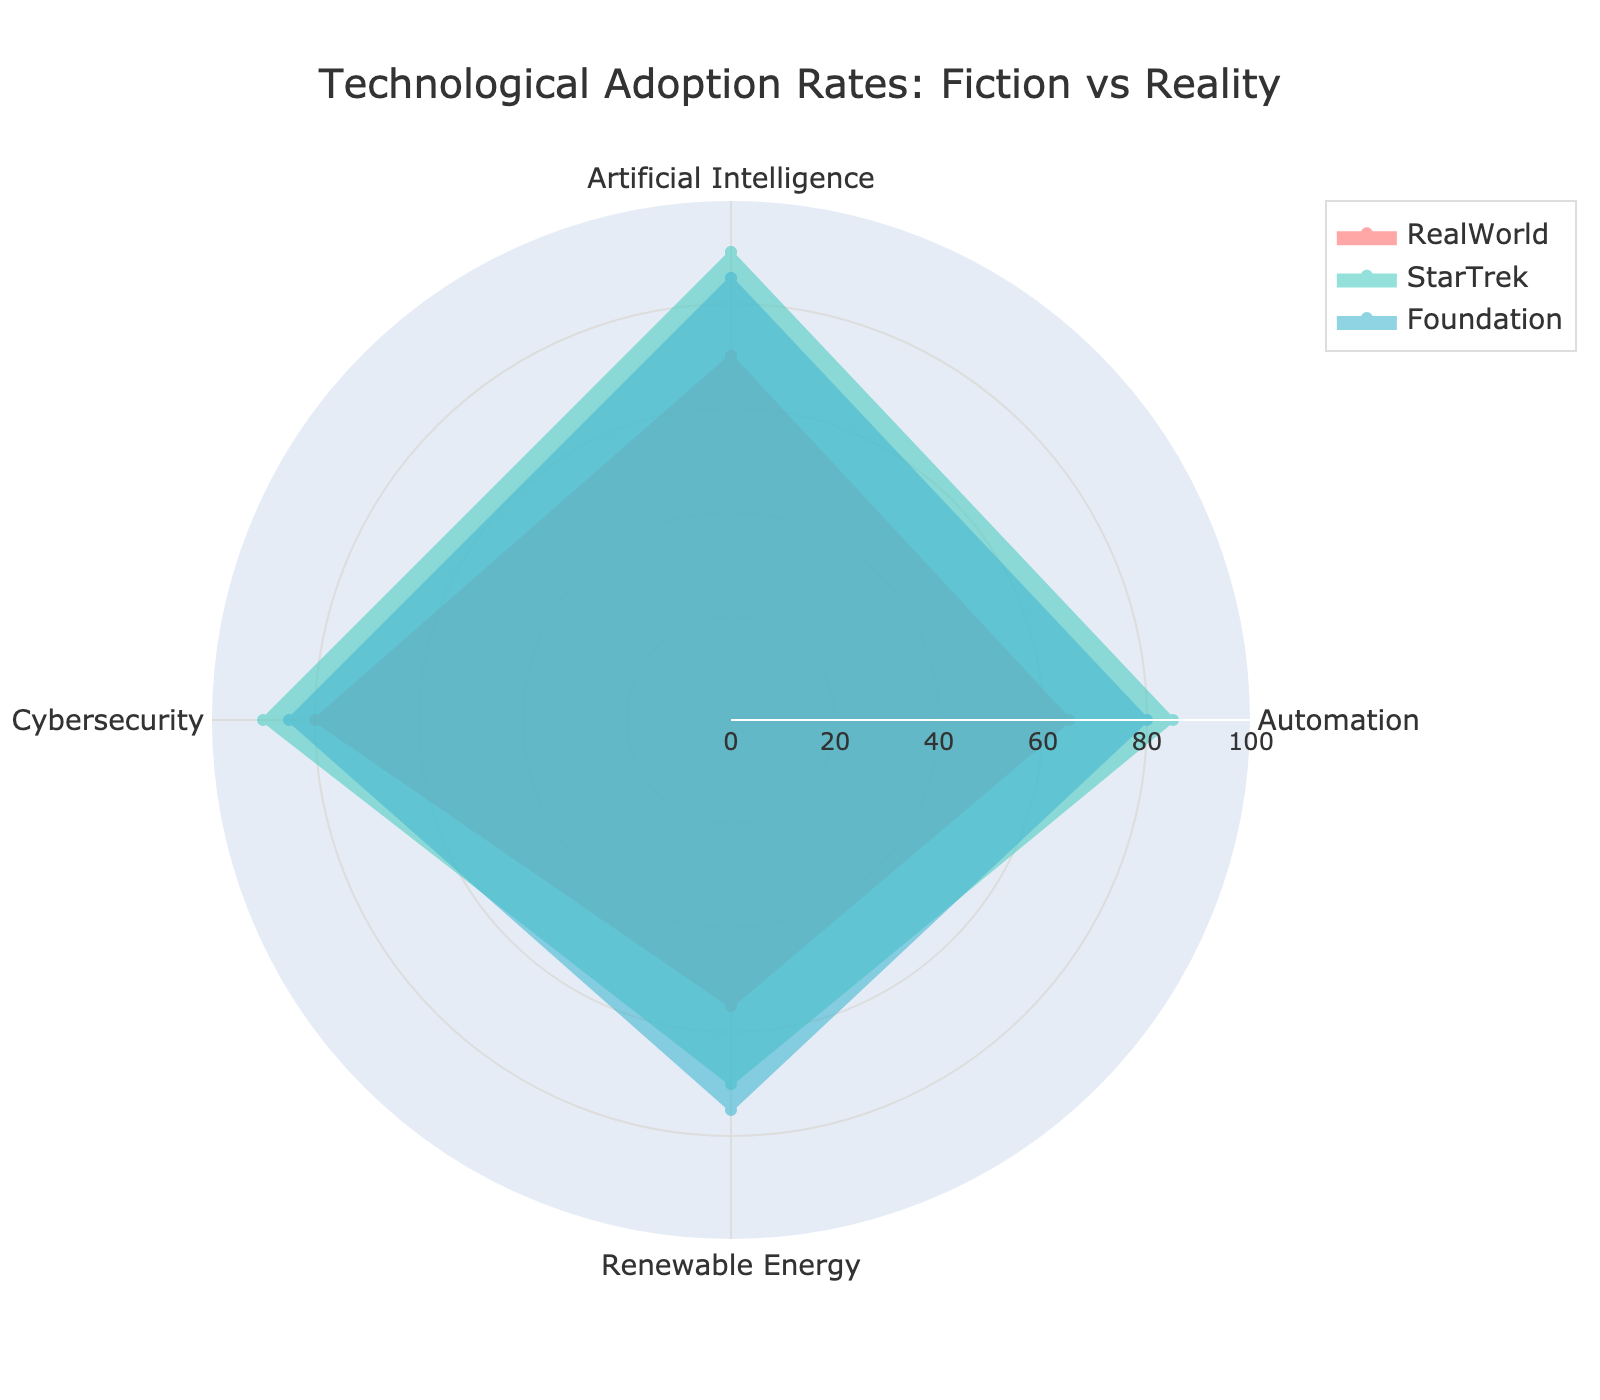what is the title of the chart? The title of the chart is usually displayed at the top center of the figure. It provides a quick understanding of what the chart is about. In this case, it is found at the top center.
Answer: Technological Adoption Rates: Fiction vs Reality Which group has the highest adoption rate for Artificial Intelligence? To determine this, we look at the values for Artificial Intelligence for each group and compare them. Star Trek group has the highest value for Artificial Intelligence.
Answer: Star Trek What is the average adoption rate of Cybersecurity across all groups? To find the average, sum the Cybersecurity values for all groups and divide by the number of groups. So, (80 + 90 + 85) / 3 = 255 / 3 = 85.
Answer: 85 Which group has the lowest adoption rate for Renewable Energy? We look at the Renewable Energy values for all groups and identify the smallest value. The RealWorld group has the lowest adoption rate for Renewable Energy.
Answer: RealWorld How many categories are shown in the radar chart? Categories refer to the different areas of technological adoption shown on the chart. By counting the categories, we find they are Artificial Intelligence, Automation, Renewable Energy, Cybersecurity.
Answer: 4 Among the listed groups, which pair has the closest adoption rates for Automation? By examining the values for Automation in each group and comparing the differences between each pair, we see Star Trek (85) and Foundation (80) have the closest adoption rates for Automation with a difference of 5.
Answer: Star Trek and Foundation What is the difference in the Renewable Energy adoption rate between Star Trek and RealWorld groups? The Renewable Energy adoption rate for Star Trek is 70, and for RealWorld, it is 55. Calculating the difference: 70 - 55 = 15.
Answer: 15 Which category has the most similar adoption rates across all three groups? By comparing the values for each category: Artificial Intelligence (70, 90, 85), Automation (65, 85, 80), Renewable Energy (55, 70, 75), Cybersecurity (80, 90, 85), we find that Cybersecurity has the most similar values across RealWorld, Star Trek, and Foundation with less variation.
Answer: Cybersecurity Which group shows a consistently high adoption rate (above 80) across all categories? By evaluating each group's values for all categories, we see that Star Trek has values of 90, 85, 70, and 90. Foundation has values of 85, 80, 75, 85. Only Star Trek meets the criteria of consistently having values above 80 in more categories compared to others.
Answer: Star Trek 